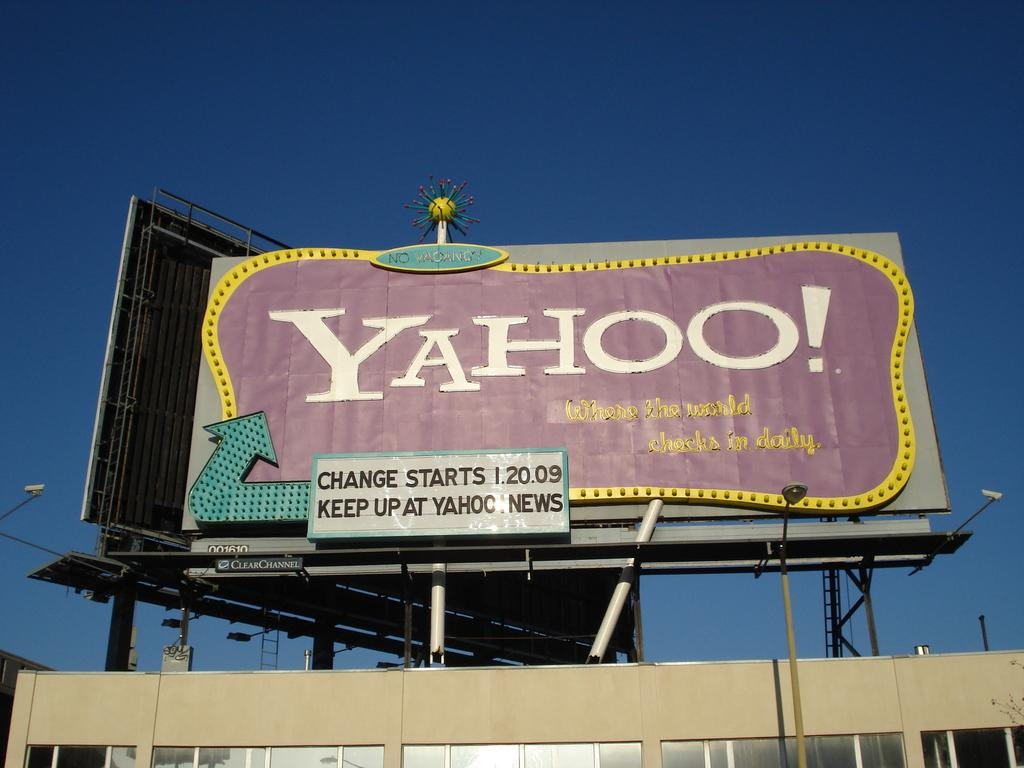<image>
Give a short and clear explanation of the subsequent image. A huge outdoor billboard by Yahoo is on a building. 